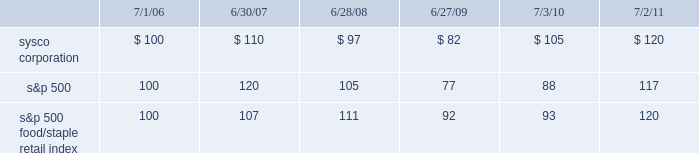Stock performance graph the following performance graph and related information shall not be deemed 201csoliciting material 201d or to be 201cfiled 201d with the securities and exchange commission , nor shall such information be incorporated by reference into any future filing under the securities act of 1933 or the securities exchange act of 1934 , each as amended , except to the extent that sysco specifically incorporates such information by reference into such filing .
The following stock performance graph compares the performance of sysco 2019s common stock to the s&p 500 index and to the s&p 500 food/ staple retail index for sysco 2019s last five fiscal years .
The graph assumes that the value of the investment in our common stock , the s&p 500 index , and the s&p 500 food/staple index was $ 100 on the last trading day of fiscal 2006 , and that all dividends were reinvested .
Performance data for sysco , the s&p 500 index and the s&p 500 food/ staple retail index is provided as of the last trading day of each of our last five fiscal years .
Comparison of 5 year cumulative total return assumes initial investment of $ 100 .

What was the difference in percentage return of sysco corporation and the s&p 500 food/staple retail index for the five years ended 7/2/11? 
Computations: (((120 - 100) / 100) - ((120 - 100) / 100))
Answer: 0.0. 